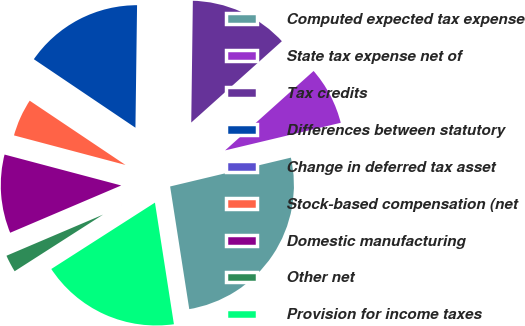<chart> <loc_0><loc_0><loc_500><loc_500><pie_chart><fcel>Computed expected tax expense<fcel>State tax expense net of<fcel>Tax credits<fcel>Differences between statutory<fcel>Change in deferred tax asset<fcel>Stock-based compensation (net<fcel>Domestic manufacturing<fcel>Other net<fcel>Provision for income taxes<nl><fcel>26.27%<fcel>7.91%<fcel>13.15%<fcel>15.77%<fcel>0.04%<fcel>5.28%<fcel>10.53%<fcel>2.66%<fcel>18.4%<nl></chart> 